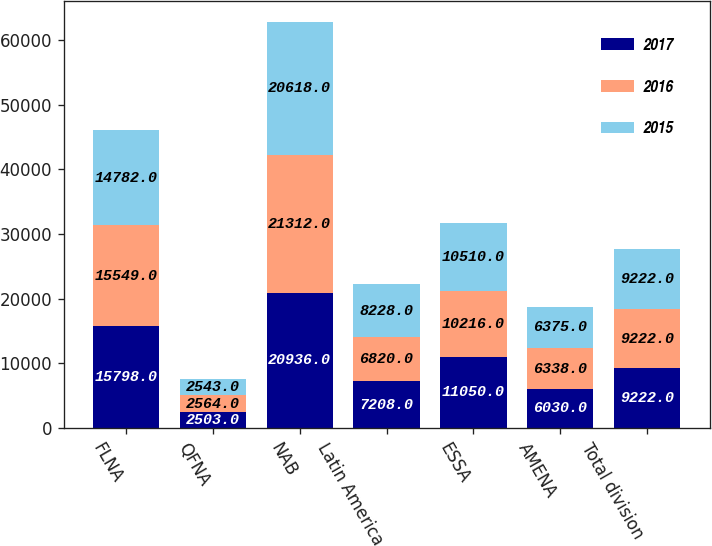Convert chart. <chart><loc_0><loc_0><loc_500><loc_500><stacked_bar_chart><ecel><fcel>FLNA<fcel>QFNA<fcel>NAB<fcel>Latin America<fcel>ESSA<fcel>AMENA<fcel>Total division<nl><fcel>2017<fcel>15798<fcel>2503<fcel>20936<fcel>7208<fcel>11050<fcel>6030<fcel>9222<nl><fcel>2016<fcel>15549<fcel>2564<fcel>21312<fcel>6820<fcel>10216<fcel>6338<fcel>9222<nl><fcel>2015<fcel>14782<fcel>2543<fcel>20618<fcel>8228<fcel>10510<fcel>6375<fcel>9222<nl></chart> 